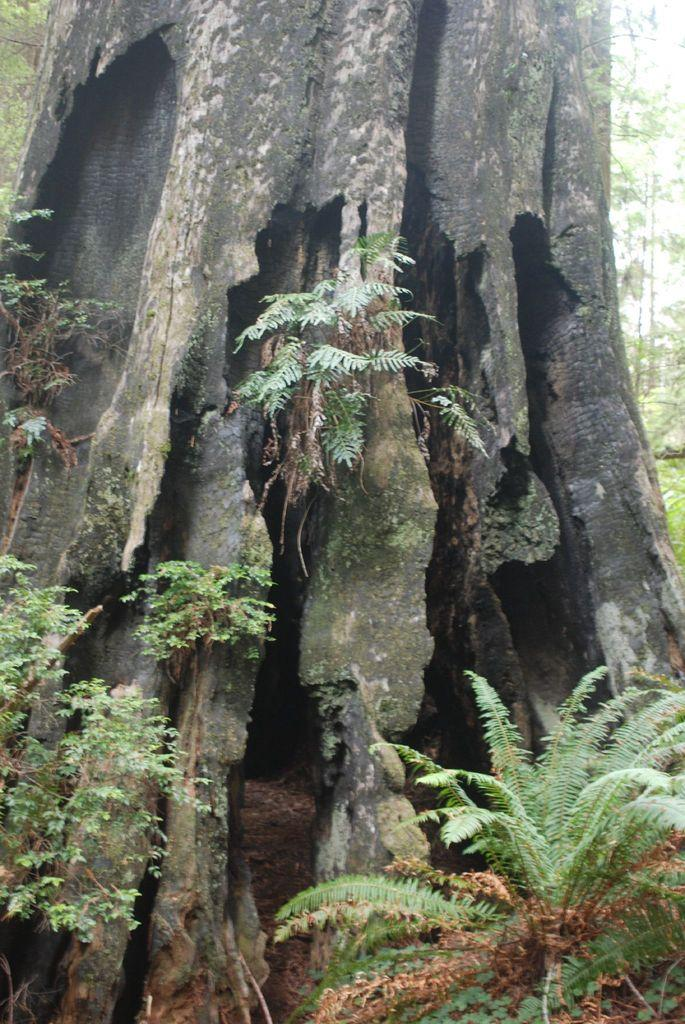What type of vegetation can be seen in the image? There are trees in the image. What is visible in the background of the image? The sky is visible in the background of the image. What type of stick is being used to make a request in the image? There is no stick or request present in the image. What position is the person in the image holding the stick? There is no person or stick present in the image. 